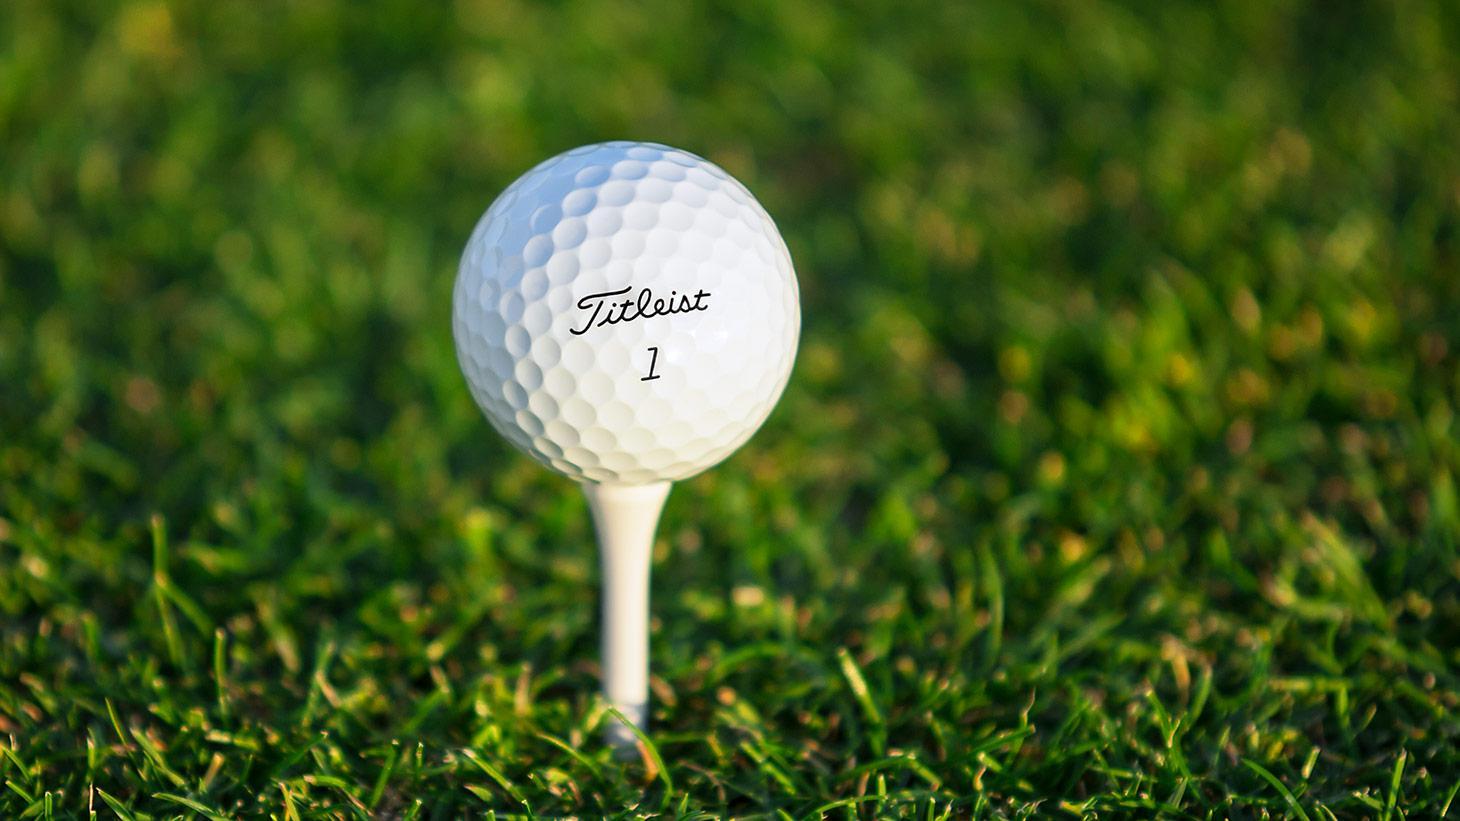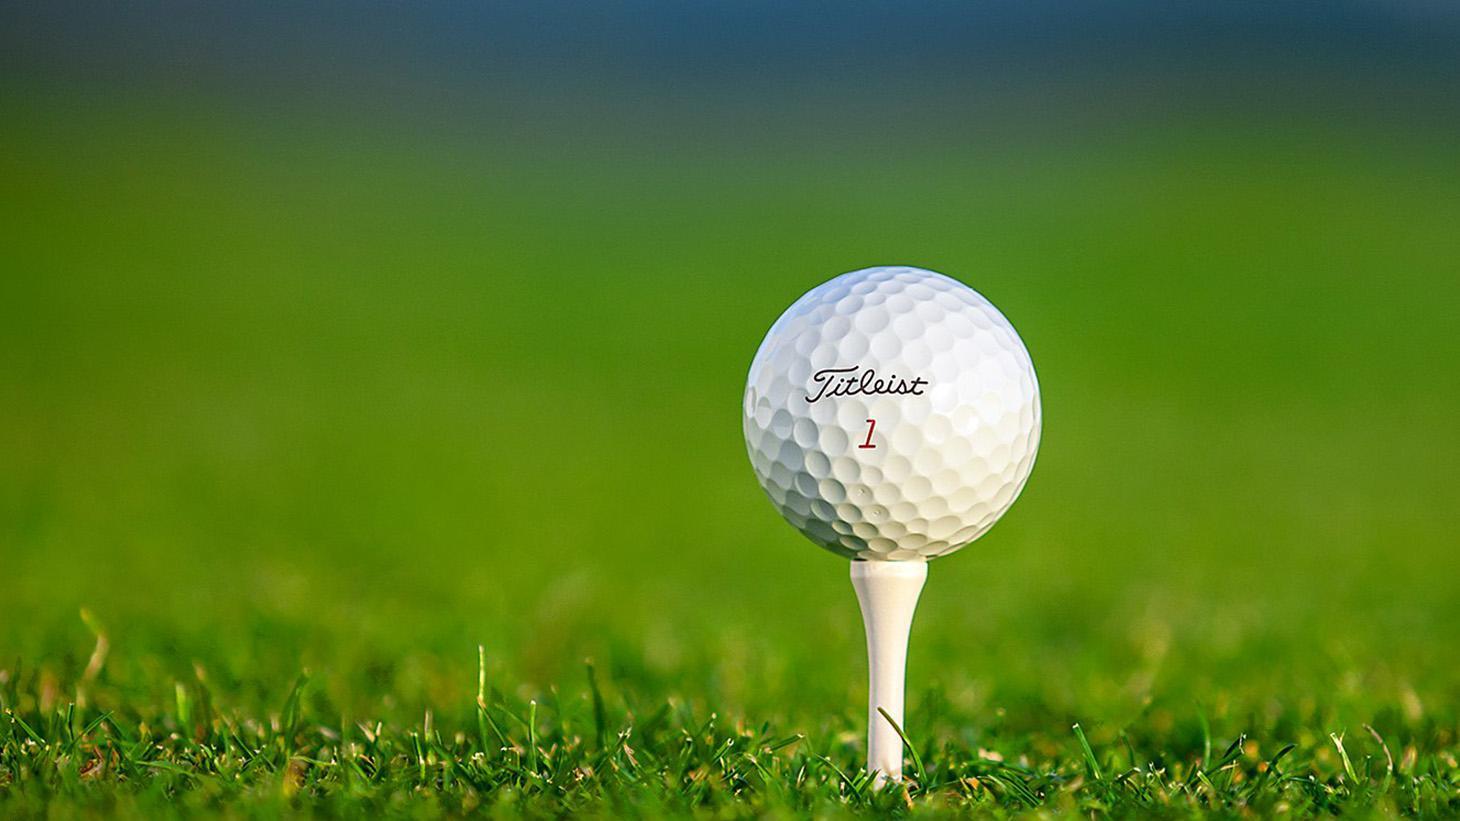The first image is the image on the left, the second image is the image on the right. Given the left and right images, does the statement "There are at least seven golf balls." hold true? Answer yes or no. No. 